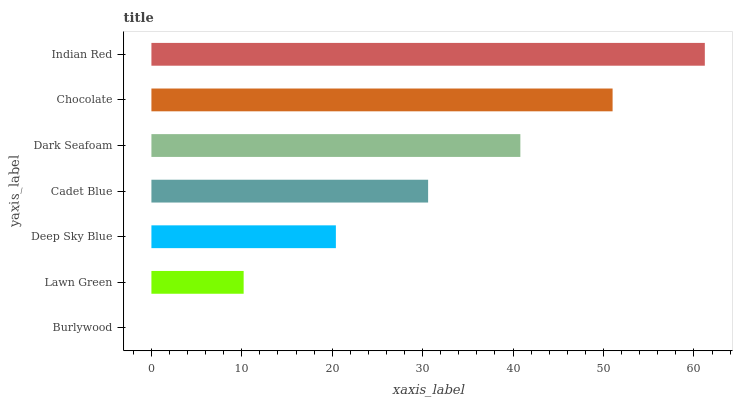Is Burlywood the minimum?
Answer yes or no. Yes. Is Indian Red the maximum?
Answer yes or no. Yes. Is Lawn Green the minimum?
Answer yes or no. No. Is Lawn Green the maximum?
Answer yes or no. No. Is Lawn Green greater than Burlywood?
Answer yes or no. Yes. Is Burlywood less than Lawn Green?
Answer yes or no. Yes. Is Burlywood greater than Lawn Green?
Answer yes or no. No. Is Lawn Green less than Burlywood?
Answer yes or no. No. Is Cadet Blue the high median?
Answer yes or no. Yes. Is Cadet Blue the low median?
Answer yes or no. Yes. Is Lawn Green the high median?
Answer yes or no. No. Is Chocolate the low median?
Answer yes or no. No. 